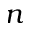Convert formula to latex. <formula><loc_0><loc_0><loc_500><loc_500>n</formula> 